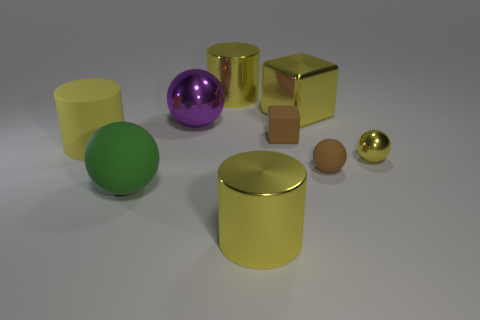Subtract all yellow metal cylinders. How many cylinders are left? 1 Subtract all yellow balls. How many balls are left? 3 Subtract 1 cylinders. How many cylinders are left? 2 Subtract all balls. How many objects are left? 5 Subtract all brown spheres. Subtract all gray cubes. How many spheres are left? 3 Subtract all big blocks. Subtract all tiny things. How many objects are left? 5 Add 1 green rubber things. How many green rubber things are left? 2 Add 4 big cylinders. How many big cylinders exist? 7 Subtract 0 purple cylinders. How many objects are left? 9 